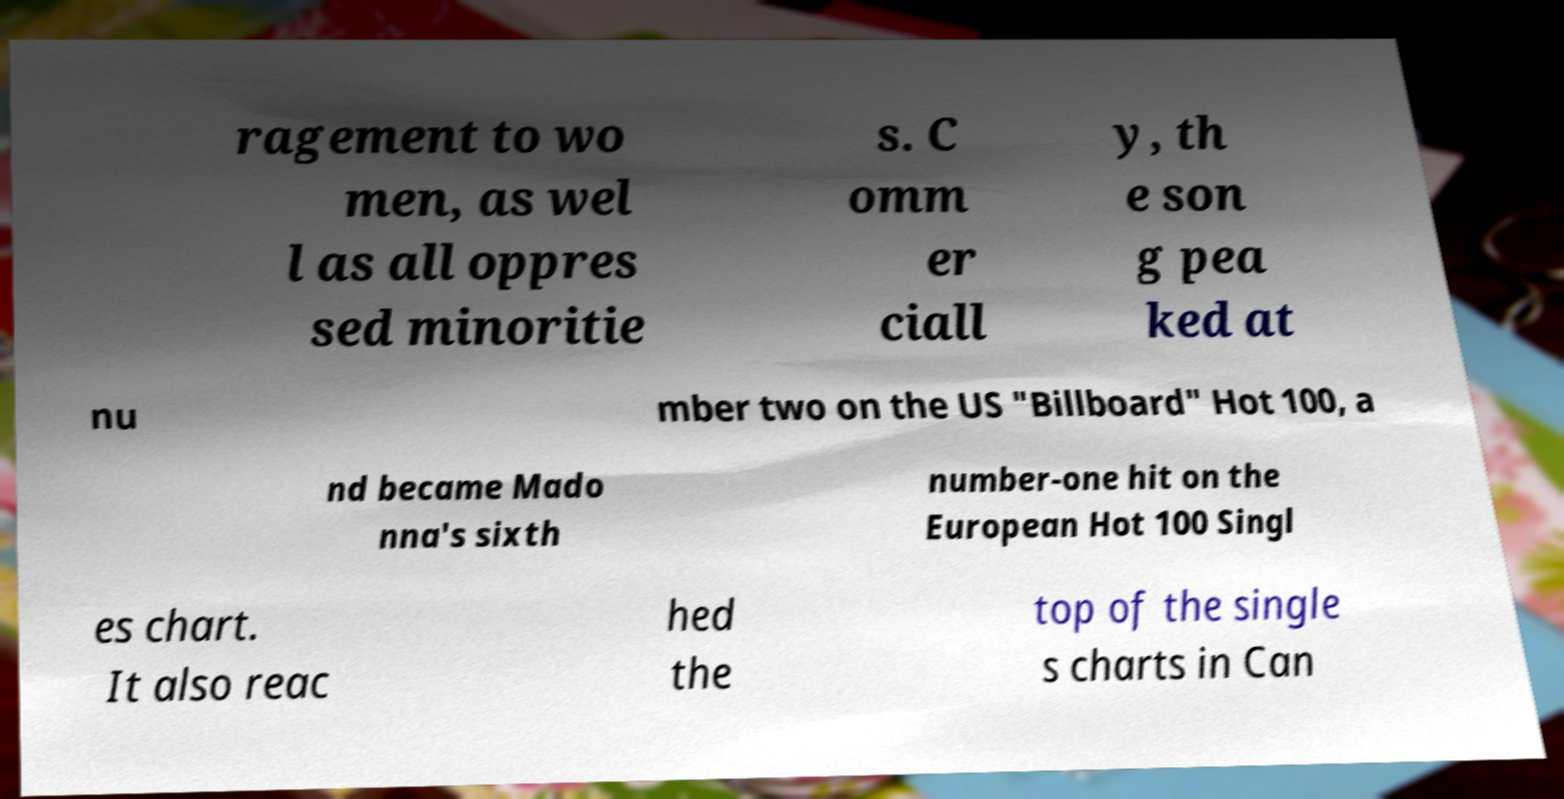I need the written content from this picture converted into text. Can you do that? ragement to wo men, as wel l as all oppres sed minoritie s. C omm er ciall y, th e son g pea ked at nu mber two on the US "Billboard" Hot 100, a nd became Mado nna's sixth number-one hit on the European Hot 100 Singl es chart. It also reac hed the top of the single s charts in Can 